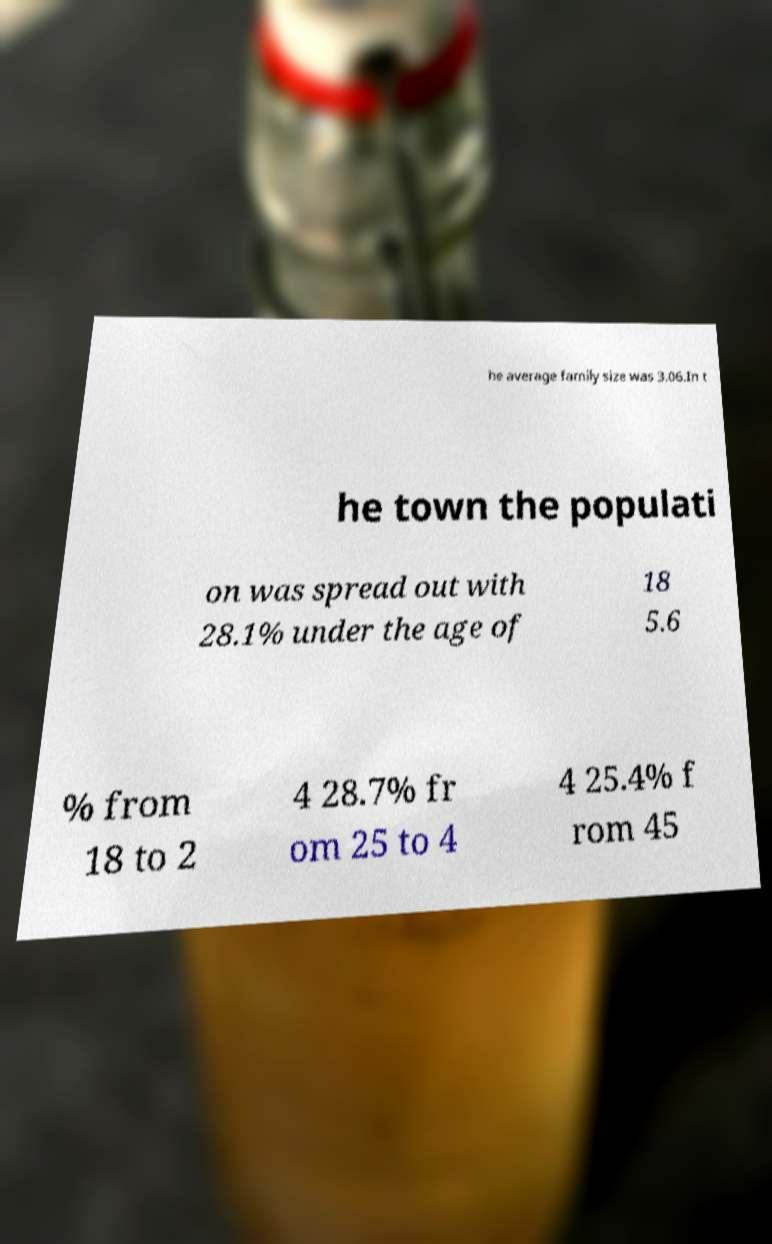I need the written content from this picture converted into text. Can you do that? he average family size was 3.06.In t he town the populati on was spread out with 28.1% under the age of 18 5.6 % from 18 to 2 4 28.7% fr om 25 to 4 4 25.4% f rom 45 